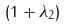<formula> <loc_0><loc_0><loc_500><loc_500>( 1 + \lambda _ { 2 } )</formula> 